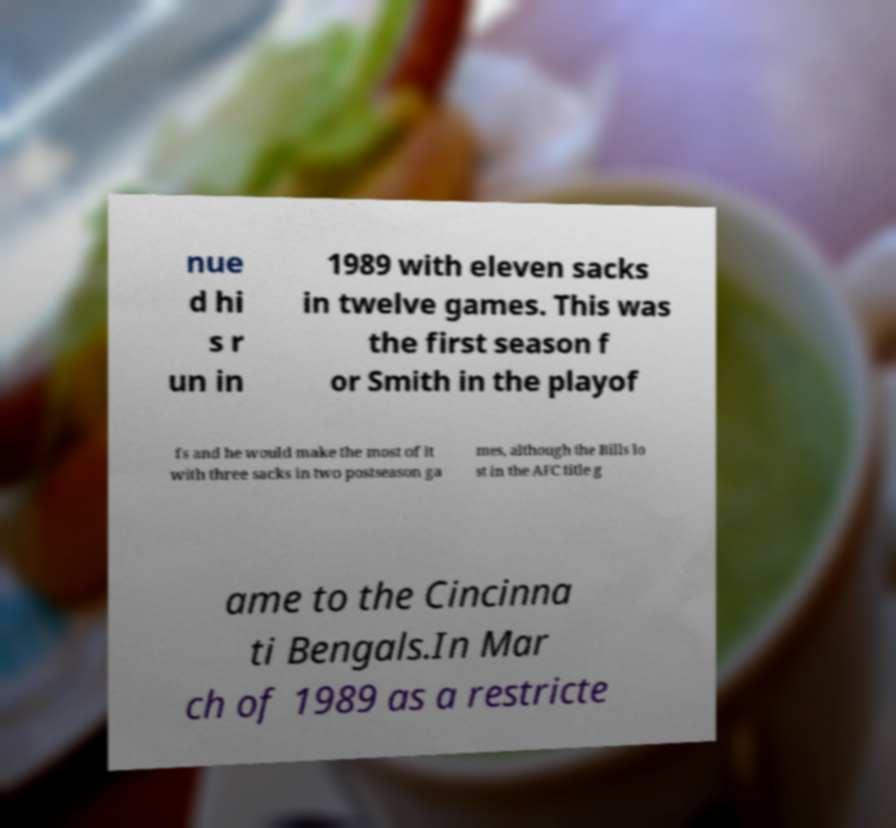For documentation purposes, I need the text within this image transcribed. Could you provide that? nue d hi s r un in 1989 with eleven sacks in twelve games. This was the first season f or Smith in the playof fs and he would make the most of it with three sacks in two postseason ga mes, although the Bills lo st in the AFC title g ame to the Cincinna ti Bengals.In Mar ch of 1989 as a restricte 